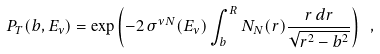Convert formula to latex. <formula><loc_0><loc_0><loc_500><loc_500>P _ { T } ( b , E _ { \nu } ) = \exp \left ( - 2 \, \sigma ^ { \nu N } ( E _ { \nu } ) \int _ { b } ^ { R } N _ { N } ( r ) \frac { r \, d r } { \sqrt { r ^ { 2 } - b ^ { 2 } } } \right ) \ ,</formula> 